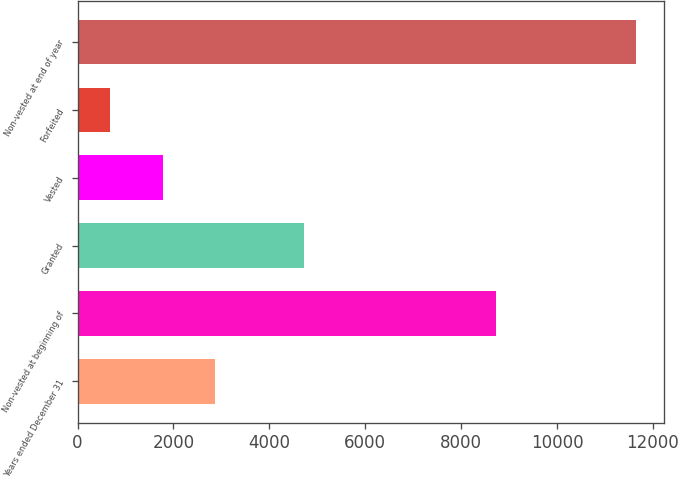Convert chart. <chart><loc_0><loc_0><loc_500><loc_500><bar_chart><fcel>Years ended December 31<fcel>Non-vested at beginning of<fcel>Granted<fcel>Vested<fcel>Forfeited<fcel>Non-vested at end of year<nl><fcel>2871.4<fcel>8738<fcel>4727<fcel>1775.2<fcel>679<fcel>11641<nl></chart> 